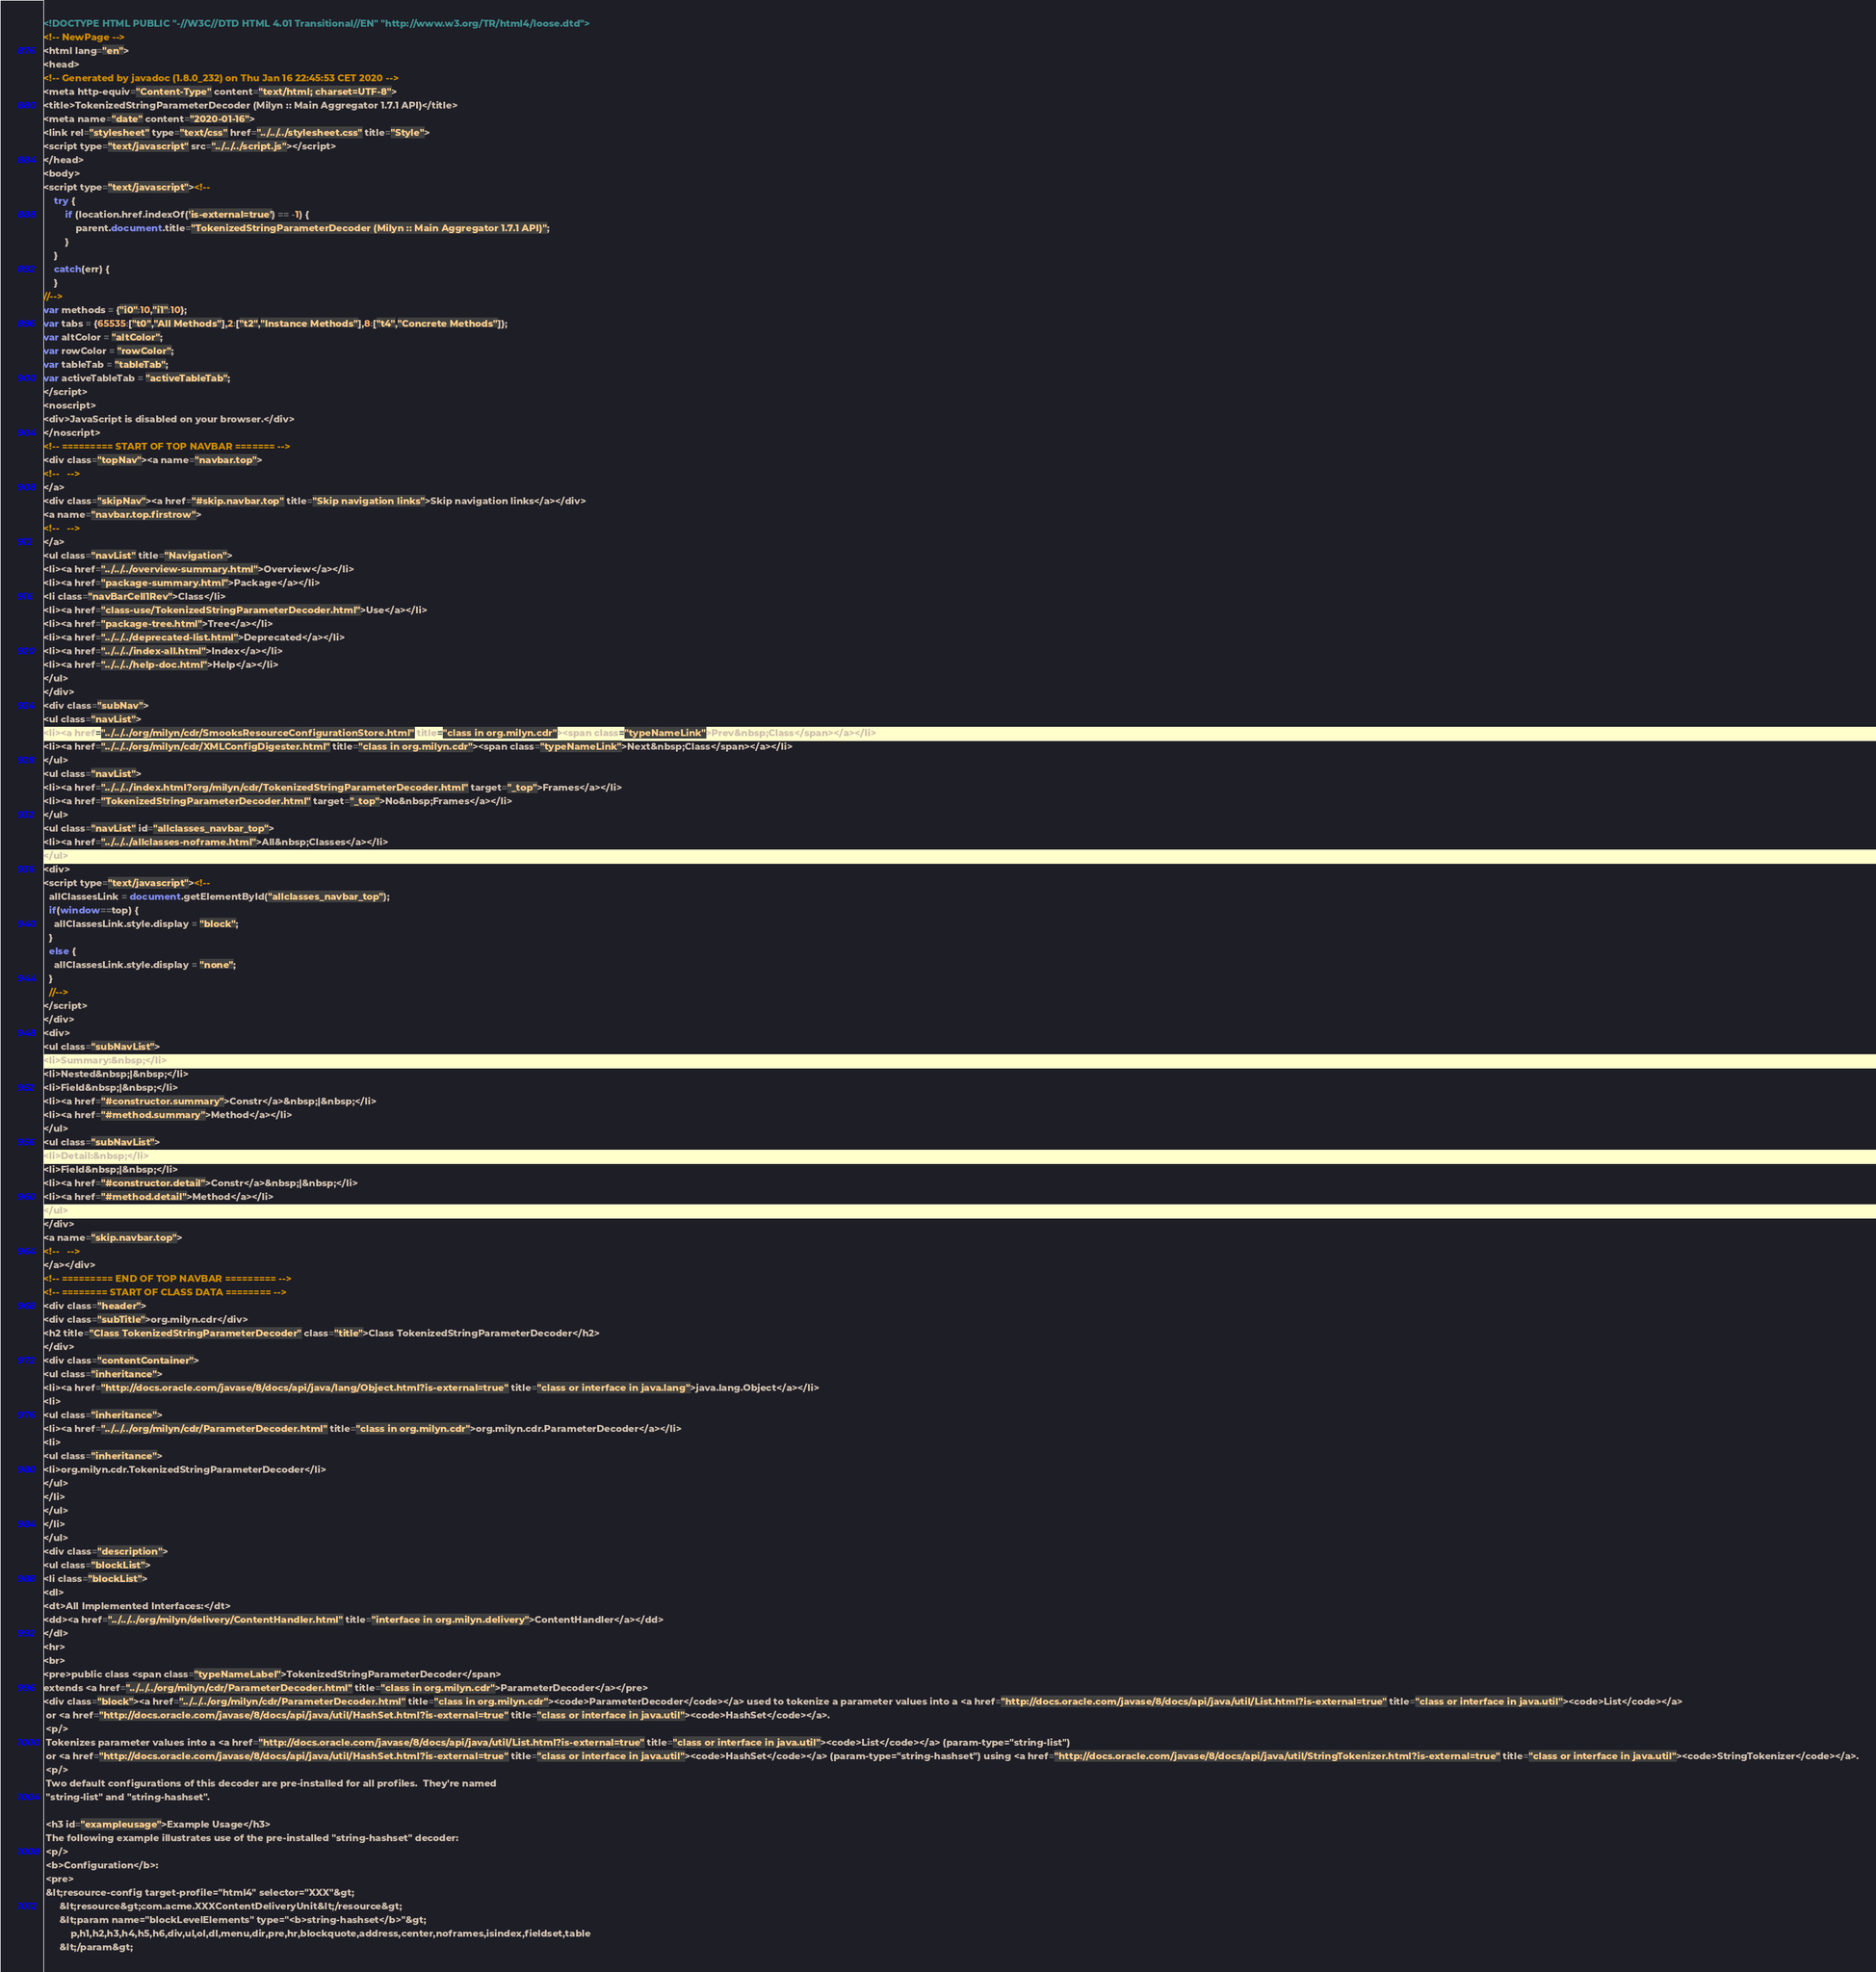Convert code to text. <code><loc_0><loc_0><loc_500><loc_500><_HTML_><!DOCTYPE HTML PUBLIC "-//W3C//DTD HTML 4.01 Transitional//EN" "http://www.w3.org/TR/html4/loose.dtd">
<!-- NewPage -->
<html lang="en">
<head>
<!-- Generated by javadoc (1.8.0_232) on Thu Jan 16 22:45:53 CET 2020 -->
<meta http-equiv="Content-Type" content="text/html; charset=UTF-8">
<title>TokenizedStringParameterDecoder (Milyn :: Main Aggregator 1.7.1 API)</title>
<meta name="date" content="2020-01-16">
<link rel="stylesheet" type="text/css" href="../../../stylesheet.css" title="Style">
<script type="text/javascript" src="../../../script.js"></script>
</head>
<body>
<script type="text/javascript"><!--
    try {
        if (location.href.indexOf('is-external=true') == -1) {
            parent.document.title="TokenizedStringParameterDecoder (Milyn :: Main Aggregator 1.7.1 API)";
        }
    }
    catch(err) {
    }
//-->
var methods = {"i0":10,"i1":10};
var tabs = {65535:["t0","All Methods"],2:["t2","Instance Methods"],8:["t4","Concrete Methods"]};
var altColor = "altColor";
var rowColor = "rowColor";
var tableTab = "tableTab";
var activeTableTab = "activeTableTab";
</script>
<noscript>
<div>JavaScript is disabled on your browser.</div>
</noscript>
<!-- ========= START OF TOP NAVBAR ======= -->
<div class="topNav"><a name="navbar.top">
<!--   -->
</a>
<div class="skipNav"><a href="#skip.navbar.top" title="Skip navigation links">Skip navigation links</a></div>
<a name="navbar.top.firstrow">
<!--   -->
</a>
<ul class="navList" title="Navigation">
<li><a href="../../../overview-summary.html">Overview</a></li>
<li><a href="package-summary.html">Package</a></li>
<li class="navBarCell1Rev">Class</li>
<li><a href="class-use/TokenizedStringParameterDecoder.html">Use</a></li>
<li><a href="package-tree.html">Tree</a></li>
<li><a href="../../../deprecated-list.html">Deprecated</a></li>
<li><a href="../../../index-all.html">Index</a></li>
<li><a href="../../../help-doc.html">Help</a></li>
</ul>
</div>
<div class="subNav">
<ul class="navList">
<li><a href="../../../org/milyn/cdr/SmooksResourceConfigurationStore.html" title="class in org.milyn.cdr"><span class="typeNameLink">Prev&nbsp;Class</span></a></li>
<li><a href="../../../org/milyn/cdr/XMLConfigDigester.html" title="class in org.milyn.cdr"><span class="typeNameLink">Next&nbsp;Class</span></a></li>
</ul>
<ul class="navList">
<li><a href="../../../index.html?org/milyn/cdr/TokenizedStringParameterDecoder.html" target="_top">Frames</a></li>
<li><a href="TokenizedStringParameterDecoder.html" target="_top">No&nbsp;Frames</a></li>
</ul>
<ul class="navList" id="allclasses_navbar_top">
<li><a href="../../../allclasses-noframe.html">All&nbsp;Classes</a></li>
</ul>
<div>
<script type="text/javascript"><!--
  allClassesLink = document.getElementById("allclasses_navbar_top");
  if(window==top) {
    allClassesLink.style.display = "block";
  }
  else {
    allClassesLink.style.display = "none";
  }
  //-->
</script>
</div>
<div>
<ul class="subNavList">
<li>Summary:&nbsp;</li>
<li>Nested&nbsp;|&nbsp;</li>
<li>Field&nbsp;|&nbsp;</li>
<li><a href="#constructor.summary">Constr</a>&nbsp;|&nbsp;</li>
<li><a href="#method.summary">Method</a></li>
</ul>
<ul class="subNavList">
<li>Detail:&nbsp;</li>
<li>Field&nbsp;|&nbsp;</li>
<li><a href="#constructor.detail">Constr</a>&nbsp;|&nbsp;</li>
<li><a href="#method.detail">Method</a></li>
</ul>
</div>
<a name="skip.navbar.top">
<!--   -->
</a></div>
<!-- ========= END OF TOP NAVBAR ========= -->
<!-- ======== START OF CLASS DATA ======== -->
<div class="header">
<div class="subTitle">org.milyn.cdr</div>
<h2 title="Class TokenizedStringParameterDecoder" class="title">Class TokenizedStringParameterDecoder</h2>
</div>
<div class="contentContainer">
<ul class="inheritance">
<li><a href="http://docs.oracle.com/javase/8/docs/api/java/lang/Object.html?is-external=true" title="class or interface in java.lang">java.lang.Object</a></li>
<li>
<ul class="inheritance">
<li><a href="../../../org/milyn/cdr/ParameterDecoder.html" title="class in org.milyn.cdr">org.milyn.cdr.ParameterDecoder</a></li>
<li>
<ul class="inheritance">
<li>org.milyn.cdr.TokenizedStringParameterDecoder</li>
</ul>
</li>
</ul>
</li>
</ul>
<div class="description">
<ul class="blockList">
<li class="blockList">
<dl>
<dt>All Implemented Interfaces:</dt>
<dd><a href="../../../org/milyn/delivery/ContentHandler.html" title="interface in org.milyn.delivery">ContentHandler</a></dd>
</dl>
<hr>
<br>
<pre>public class <span class="typeNameLabel">TokenizedStringParameterDecoder</span>
extends <a href="../../../org/milyn/cdr/ParameterDecoder.html" title="class in org.milyn.cdr">ParameterDecoder</a></pre>
<div class="block"><a href="../../../org/milyn/cdr/ParameterDecoder.html" title="class in org.milyn.cdr"><code>ParameterDecoder</code></a> used to tokenize a parameter values into a <a href="http://docs.oracle.com/javase/8/docs/api/java/util/List.html?is-external=true" title="class or interface in java.util"><code>List</code></a>
 or <a href="http://docs.oracle.com/javase/8/docs/api/java/util/HashSet.html?is-external=true" title="class or interface in java.util"><code>HashSet</code></a>.
 <p/>
 Tokenizes parameter values into a <a href="http://docs.oracle.com/javase/8/docs/api/java/util/List.html?is-external=true" title="class or interface in java.util"><code>List</code></a> (param-type="string-list")
 or <a href="http://docs.oracle.com/javase/8/docs/api/java/util/HashSet.html?is-external=true" title="class or interface in java.util"><code>HashSet</code></a> (param-type="string-hashset") using <a href="http://docs.oracle.com/javase/8/docs/api/java/util/StringTokenizer.html?is-external=true" title="class or interface in java.util"><code>StringTokenizer</code></a>.
 <p/>
 Two default configurations of this decoder are pre-installed for all profiles.  They're named
 "string-list" and "string-hashset".

 <h3 id="exampleusage">Example Usage</h3>
 The following example illustrates use of the pre-installed "string-hashset" decoder:
 <p/>
 <b>Configuration</b>:
 <pre>
 &lt;resource-config target-profile="html4" selector="XXX"&gt;
      &lt;resource&gt;com.acme.XXXContentDeliveryUnit&lt;/resource&gt;
      &lt;param name="blockLevelElements" type="<b>string-hashset</b>"&gt;
          p,h1,h2,h3,h4,h5,h6,div,ul,ol,dl,menu,dir,pre,hr,blockquote,address,center,noframes,isindex,fieldset,table
      &lt;/param&gt;</code> 